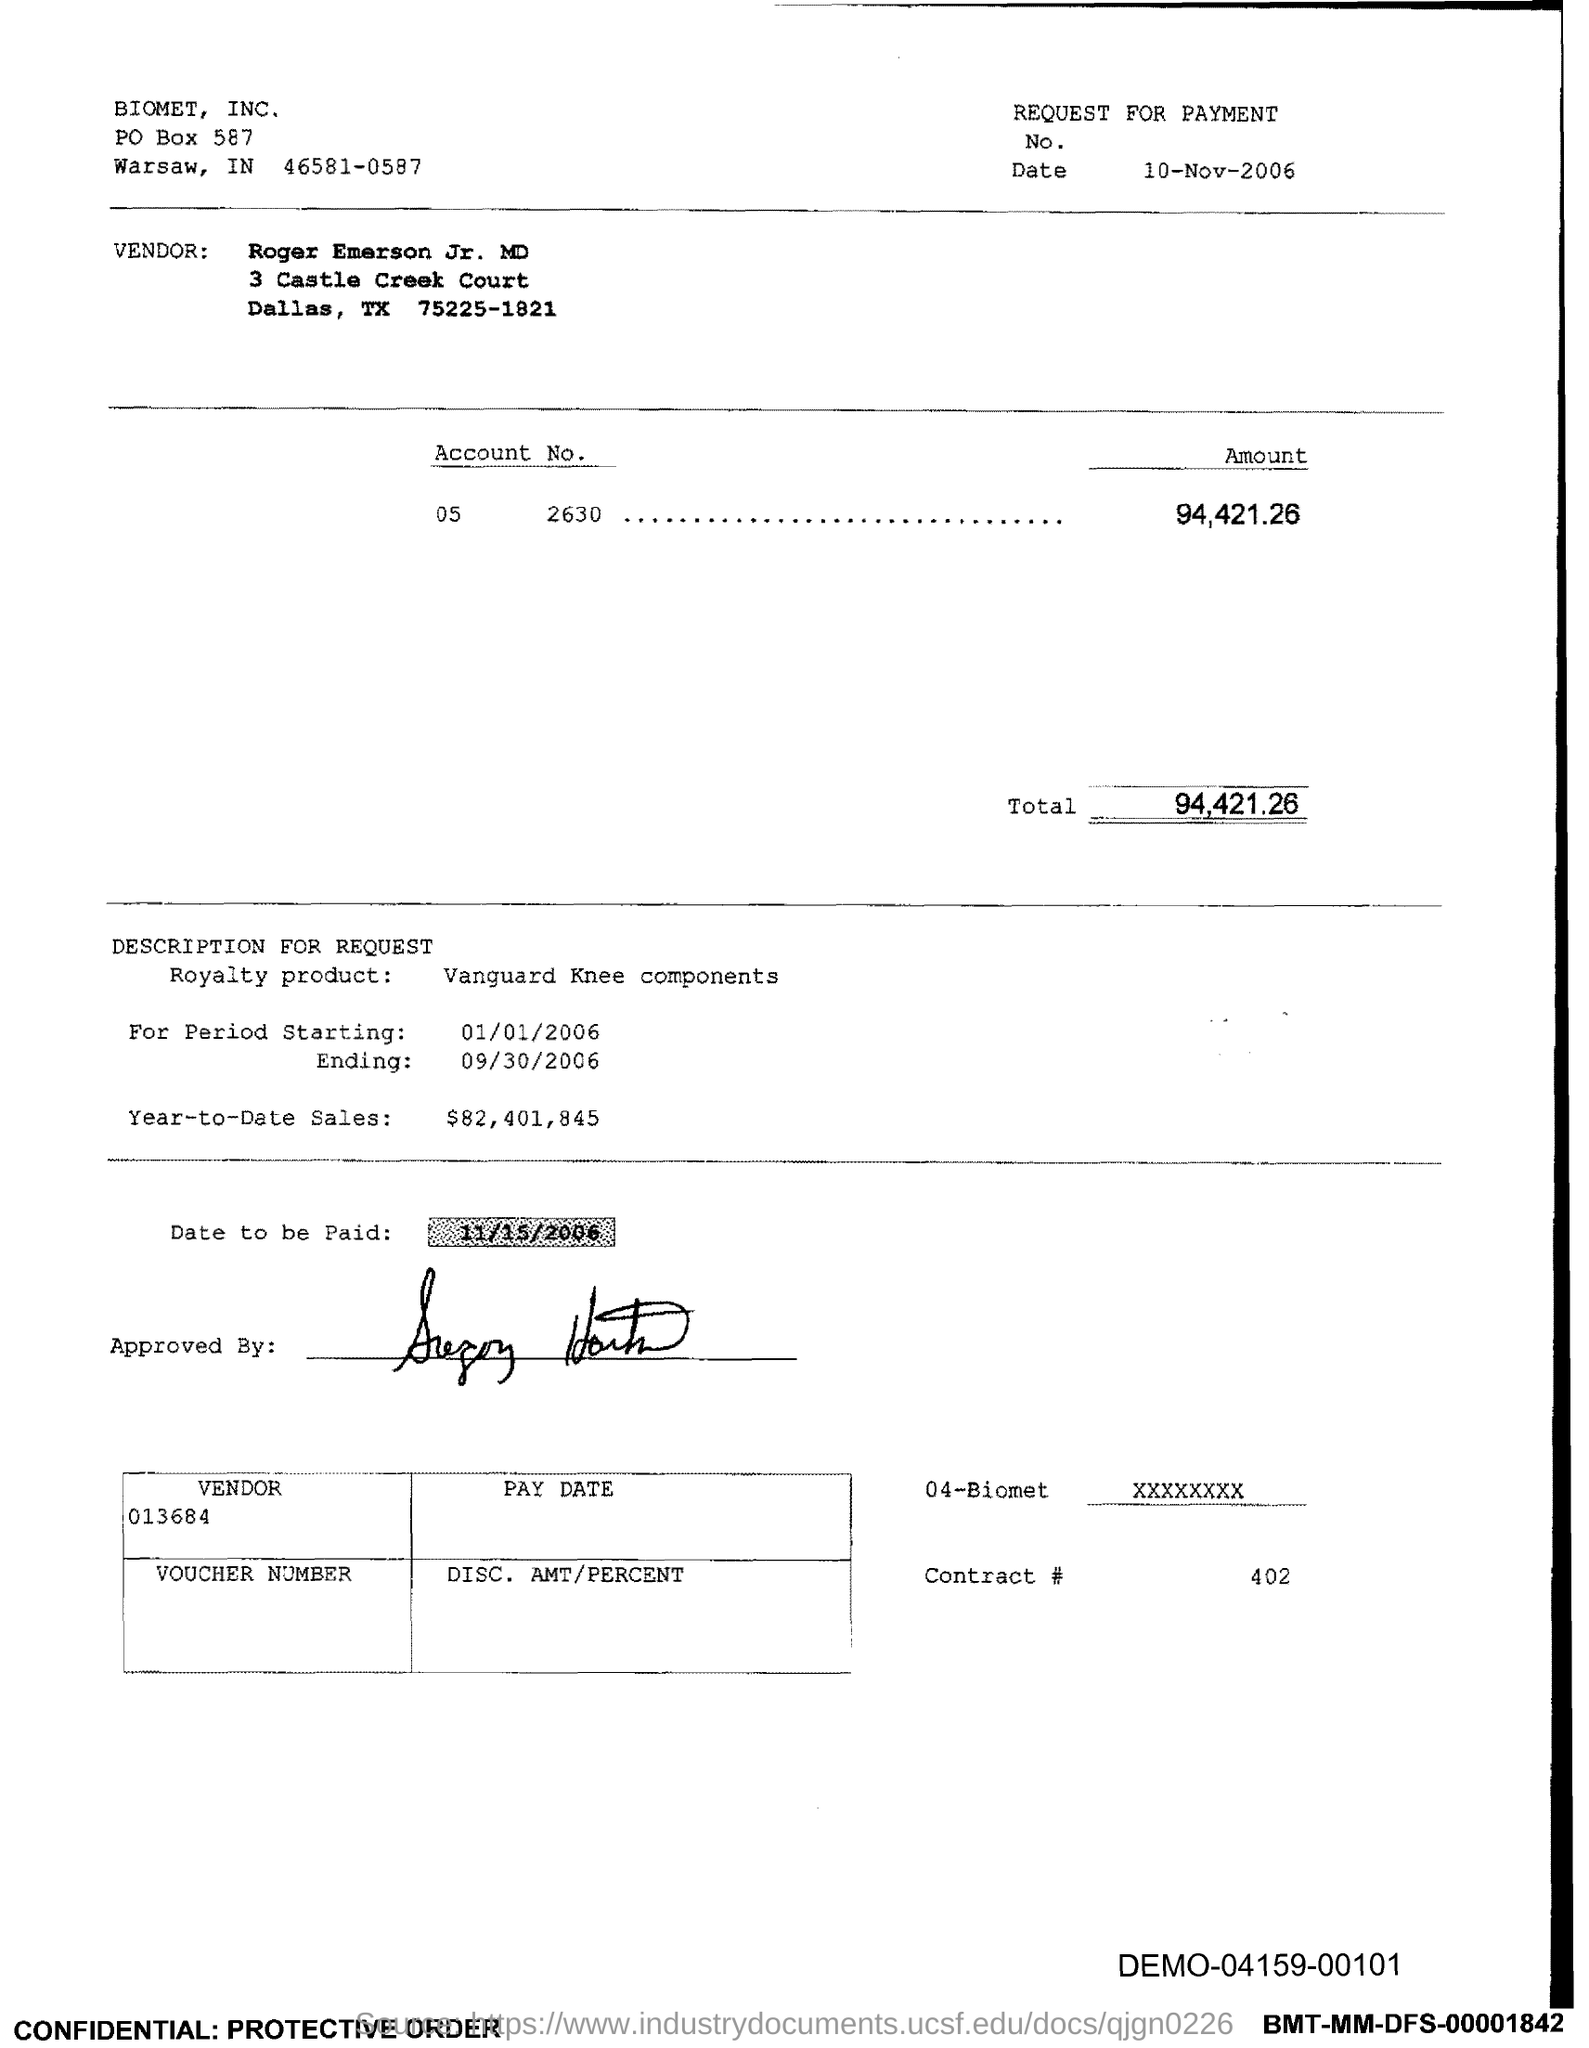What is the PO Box Number mentioned in the document?
Offer a very short reply. 587. What is the Total?
Make the answer very short. 94,421.26. What is the date to be paid?
Your response must be concise. 11/15/2006. 